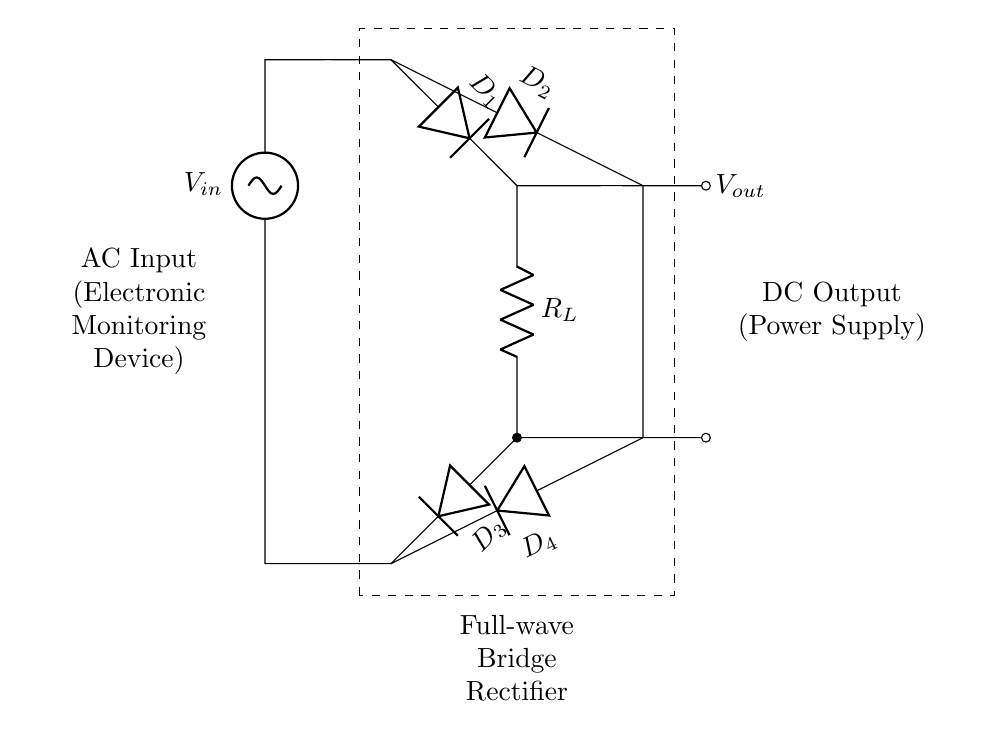What type of rectifier is used in this circuit? The circuit includes four diodes arranged in a specific configuration, which characterizes it as a full-wave bridge rectifier.
Answer: Full-wave bridge rectifier How many diodes are present in the circuit? The diagram shows four distinct diodes labeled D1, D2, D3, and D4 in the circuit, confirming the total count.
Answer: Four diodes What is the input voltage type for this rectifier? The diagram indicates an AC input source labeled V_in at the top, specifying that the rectifier is designed to convert alternating current.
Answer: AC Where is the load resistor located in the circuit? The load resistor, labeled R_L, is positioned at the output path after the diodes in the circuit, indicating where the power is delivered.
Answer: Between D1 and D3 What is the purpose of the diodes in this circuit? The primary role of the diodes in a bridge rectifier configuration is to allow current to flow in one direction only, enabling the conversion of AC to DC.
Answer: Convert AC to DC What is the output voltage designation in the circuit? The output voltage is specified at V_out, indicating where the output of the converted current can be accessed.
Answer: V_out Which component provides the DC output in this rectifier? In the circuit, the combination of the four diodes plays the crucial role of allowing rectified current to flow towards the load, thus providing the DC output to the circuit.
Answer: The four diodes 